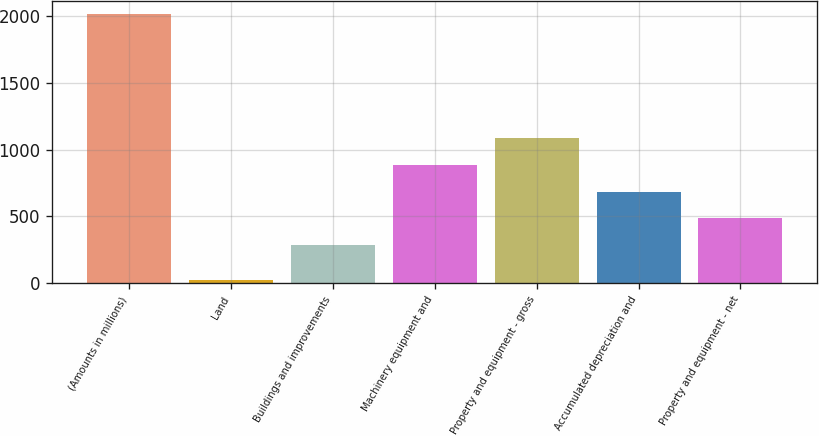Convert chart to OTSL. <chart><loc_0><loc_0><loc_500><loc_500><bar_chart><fcel>(Amounts in millions)<fcel>Land<fcel>Buildings and improvements<fcel>Machinery equipment and<fcel>Property and equipment - gross<fcel>Accumulated depreciation and<fcel>Property and equipment - net<nl><fcel>2012<fcel>19.4<fcel>286.2<fcel>883.98<fcel>1083.24<fcel>684.72<fcel>485.46<nl></chart> 